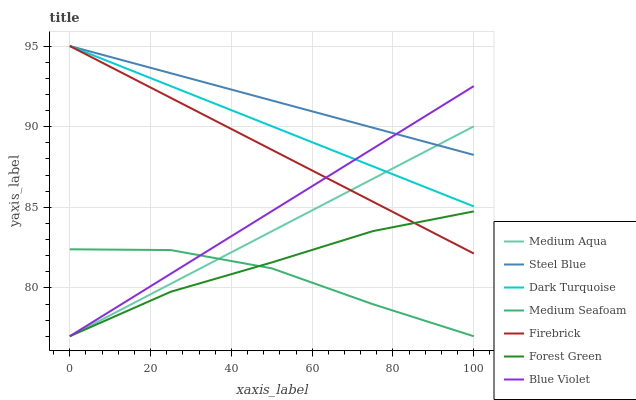Does Medium Seafoam have the minimum area under the curve?
Answer yes or no. Yes. Does Steel Blue have the maximum area under the curve?
Answer yes or no. Yes. Does Firebrick have the minimum area under the curve?
Answer yes or no. No. Does Firebrick have the maximum area under the curve?
Answer yes or no. No. Is Firebrick the smoothest?
Answer yes or no. Yes. Is Medium Seafoam the roughest?
Answer yes or no. Yes. Is Steel Blue the smoothest?
Answer yes or no. No. Is Steel Blue the roughest?
Answer yes or no. No. Does Forest Green have the lowest value?
Answer yes or no. Yes. Does Firebrick have the lowest value?
Answer yes or no. No. Does Steel Blue have the highest value?
Answer yes or no. Yes. Does Forest Green have the highest value?
Answer yes or no. No. Is Medium Seafoam less than Dark Turquoise?
Answer yes or no. Yes. Is Dark Turquoise greater than Forest Green?
Answer yes or no. Yes. Does Medium Aqua intersect Dark Turquoise?
Answer yes or no. Yes. Is Medium Aqua less than Dark Turquoise?
Answer yes or no. No. Is Medium Aqua greater than Dark Turquoise?
Answer yes or no. No. Does Medium Seafoam intersect Dark Turquoise?
Answer yes or no. No. 